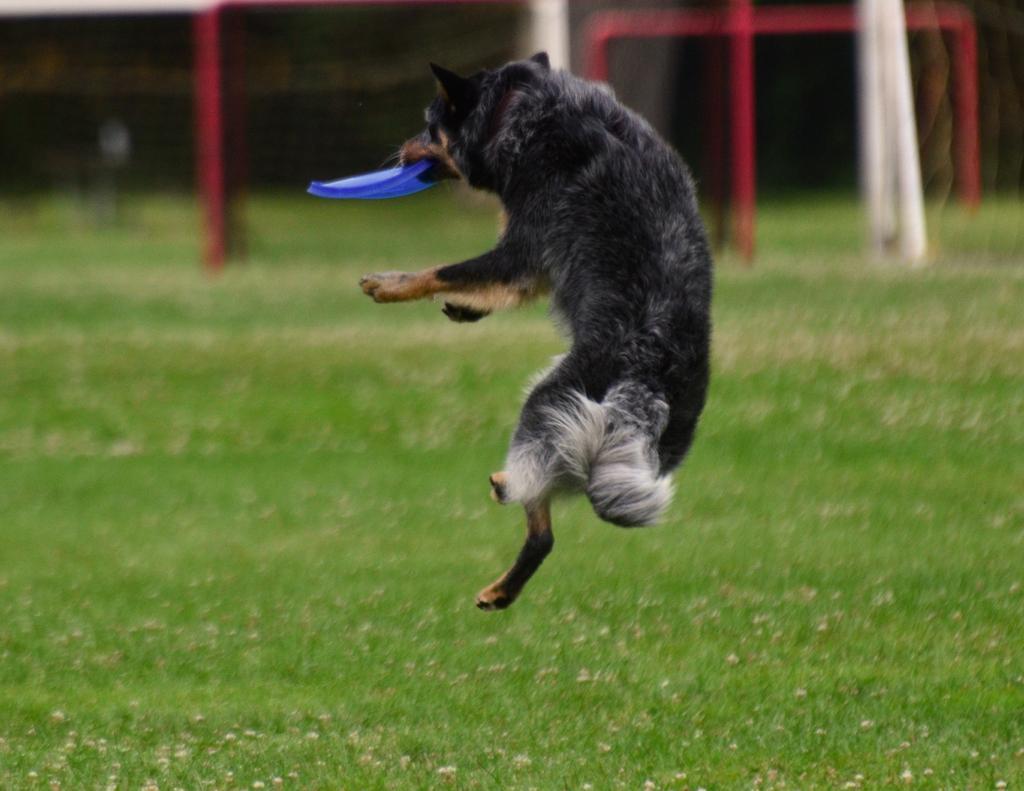In one or two sentences, can you explain what this image depicts? In this picture we can see a dog holding an object with it's mouth and this dog is in the air and in the background we can see grass and some objects. 